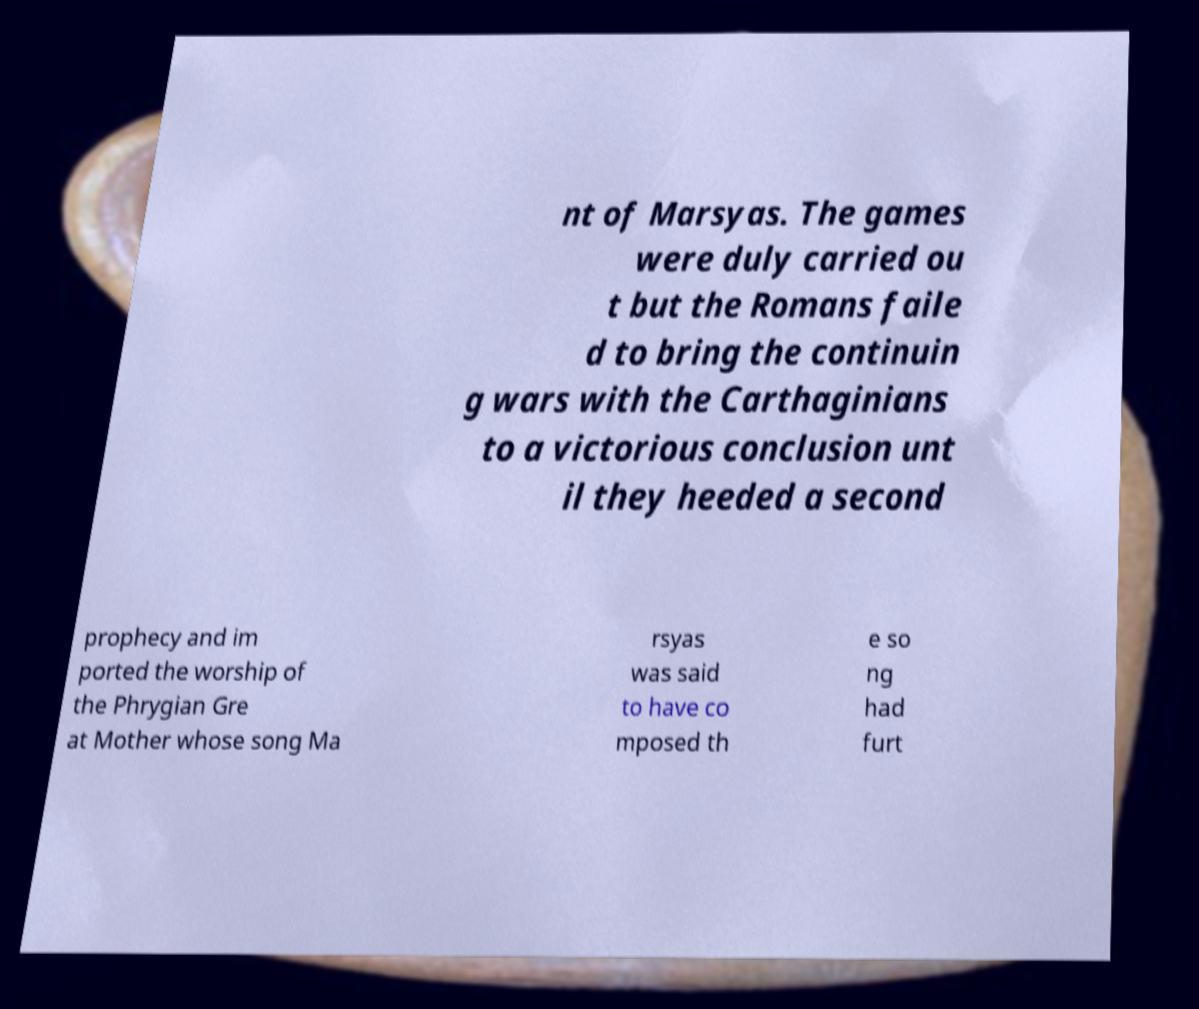Can you accurately transcribe the text from the provided image for me? nt of Marsyas. The games were duly carried ou t but the Romans faile d to bring the continuin g wars with the Carthaginians to a victorious conclusion unt il they heeded a second prophecy and im ported the worship of the Phrygian Gre at Mother whose song Ma rsyas was said to have co mposed th e so ng had furt 